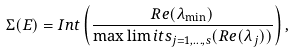Convert formula to latex. <formula><loc_0><loc_0><loc_500><loc_500>\Sigma ( E ) = I n t \left ( \frac { R e ( \lambda _ { \min } ) } { \max \lim i t s _ { j = 1 , \dots , s } ( R e ( \lambda _ { j } ) ) } \right ) ,</formula> 